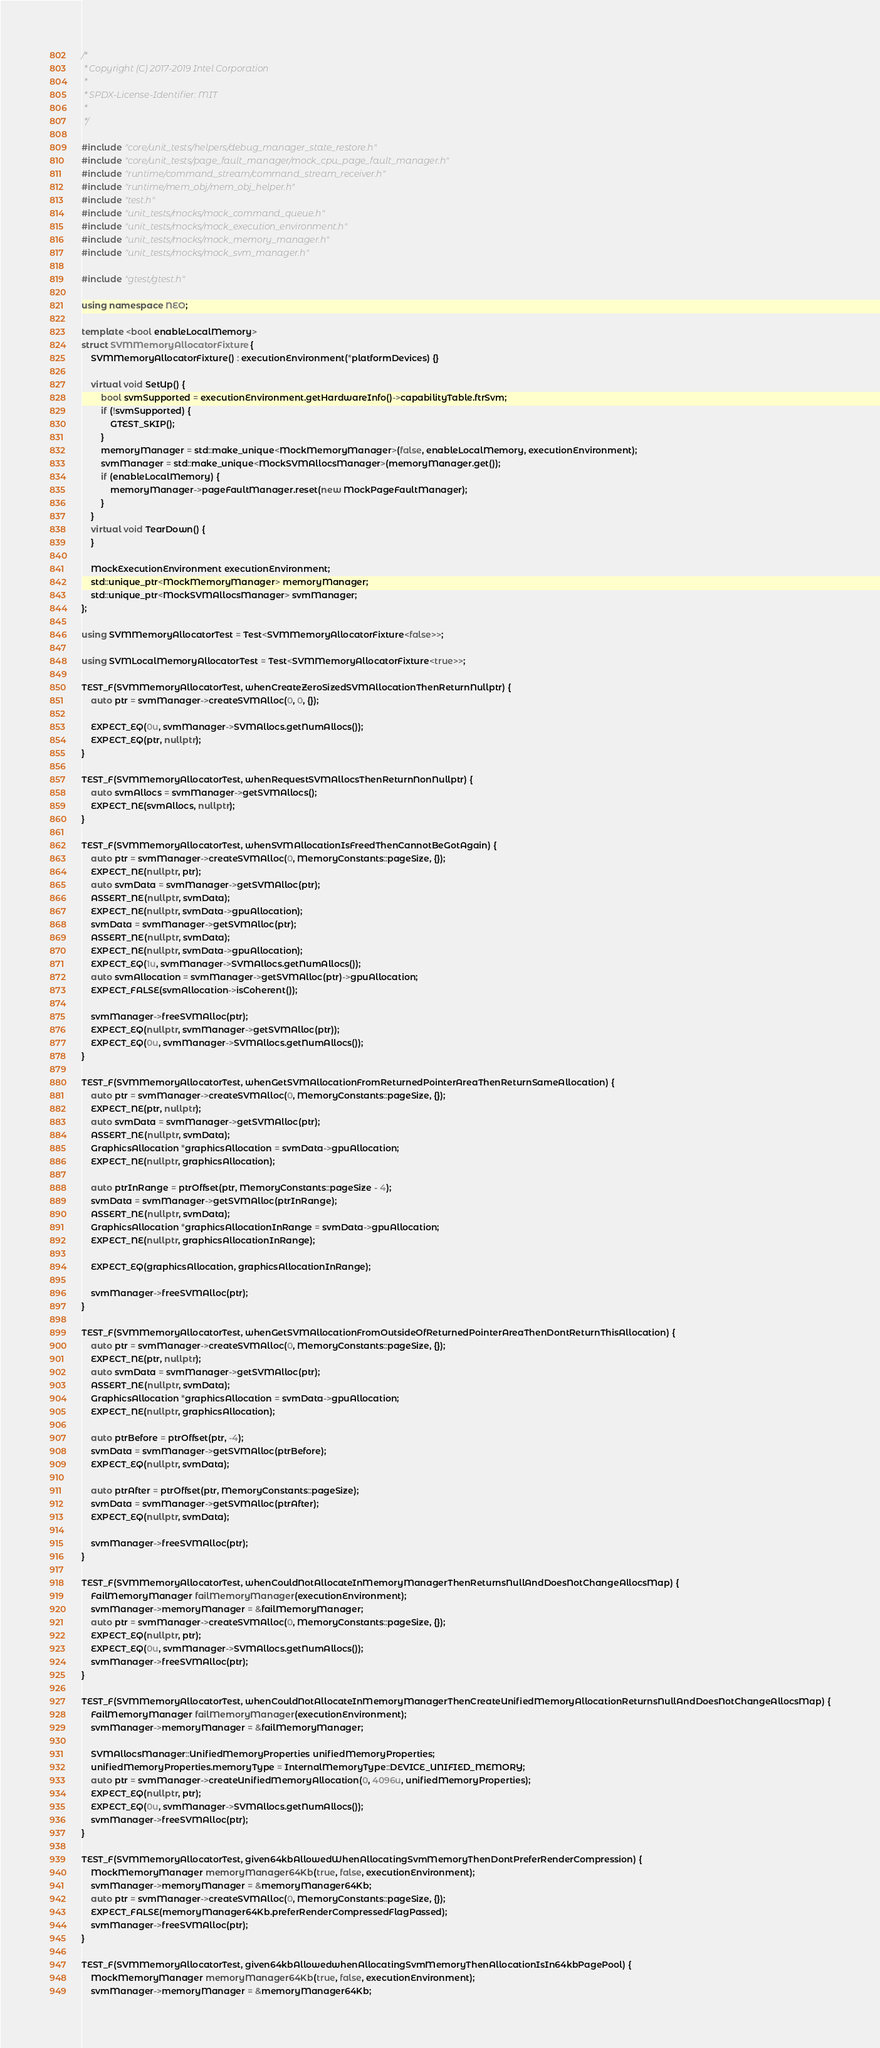<code> <loc_0><loc_0><loc_500><loc_500><_C++_>/*
 * Copyright (C) 2017-2019 Intel Corporation
 *
 * SPDX-License-Identifier: MIT
 *
 */

#include "core/unit_tests/helpers/debug_manager_state_restore.h"
#include "core/unit_tests/page_fault_manager/mock_cpu_page_fault_manager.h"
#include "runtime/command_stream/command_stream_receiver.h"
#include "runtime/mem_obj/mem_obj_helper.h"
#include "test.h"
#include "unit_tests/mocks/mock_command_queue.h"
#include "unit_tests/mocks/mock_execution_environment.h"
#include "unit_tests/mocks/mock_memory_manager.h"
#include "unit_tests/mocks/mock_svm_manager.h"

#include "gtest/gtest.h"

using namespace NEO;

template <bool enableLocalMemory>
struct SVMMemoryAllocatorFixture {
    SVMMemoryAllocatorFixture() : executionEnvironment(*platformDevices) {}

    virtual void SetUp() {
        bool svmSupported = executionEnvironment.getHardwareInfo()->capabilityTable.ftrSvm;
        if (!svmSupported) {
            GTEST_SKIP();
        }
        memoryManager = std::make_unique<MockMemoryManager>(false, enableLocalMemory, executionEnvironment);
        svmManager = std::make_unique<MockSVMAllocsManager>(memoryManager.get());
        if (enableLocalMemory) {
            memoryManager->pageFaultManager.reset(new MockPageFaultManager);
        }
    }
    virtual void TearDown() {
    }

    MockExecutionEnvironment executionEnvironment;
    std::unique_ptr<MockMemoryManager> memoryManager;
    std::unique_ptr<MockSVMAllocsManager> svmManager;
};

using SVMMemoryAllocatorTest = Test<SVMMemoryAllocatorFixture<false>>;

using SVMLocalMemoryAllocatorTest = Test<SVMMemoryAllocatorFixture<true>>;

TEST_F(SVMMemoryAllocatorTest, whenCreateZeroSizedSVMAllocationThenReturnNullptr) {
    auto ptr = svmManager->createSVMAlloc(0, 0, {});

    EXPECT_EQ(0u, svmManager->SVMAllocs.getNumAllocs());
    EXPECT_EQ(ptr, nullptr);
}

TEST_F(SVMMemoryAllocatorTest, whenRequestSVMAllocsThenReturnNonNullptr) {
    auto svmAllocs = svmManager->getSVMAllocs();
    EXPECT_NE(svmAllocs, nullptr);
}

TEST_F(SVMMemoryAllocatorTest, whenSVMAllocationIsFreedThenCannotBeGotAgain) {
    auto ptr = svmManager->createSVMAlloc(0, MemoryConstants::pageSize, {});
    EXPECT_NE(nullptr, ptr);
    auto svmData = svmManager->getSVMAlloc(ptr);
    ASSERT_NE(nullptr, svmData);
    EXPECT_NE(nullptr, svmData->gpuAllocation);
    svmData = svmManager->getSVMAlloc(ptr);
    ASSERT_NE(nullptr, svmData);
    EXPECT_NE(nullptr, svmData->gpuAllocation);
    EXPECT_EQ(1u, svmManager->SVMAllocs.getNumAllocs());
    auto svmAllocation = svmManager->getSVMAlloc(ptr)->gpuAllocation;
    EXPECT_FALSE(svmAllocation->isCoherent());

    svmManager->freeSVMAlloc(ptr);
    EXPECT_EQ(nullptr, svmManager->getSVMAlloc(ptr));
    EXPECT_EQ(0u, svmManager->SVMAllocs.getNumAllocs());
}

TEST_F(SVMMemoryAllocatorTest, whenGetSVMAllocationFromReturnedPointerAreaThenReturnSameAllocation) {
    auto ptr = svmManager->createSVMAlloc(0, MemoryConstants::pageSize, {});
    EXPECT_NE(ptr, nullptr);
    auto svmData = svmManager->getSVMAlloc(ptr);
    ASSERT_NE(nullptr, svmData);
    GraphicsAllocation *graphicsAllocation = svmData->gpuAllocation;
    EXPECT_NE(nullptr, graphicsAllocation);

    auto ptrInRange = ptrOffset(ptr, MemoryConstants::pageSize - 4);
    svmData = svmManager->getSVMAlloc(ptrInRange);
    ASSERT_NE(nullptr, svmData);
    GraphicsAllocation *graphicsAllocationInRange = svmData->gpuAllocation;
    EXPECT_NE(nullptr, graphicsAllocationInRange);

    EXPECT_EQ(graphicsAllocation, graphicsAllocationInRange);

    svmManager->freeSVMAlloc(ptr);
}

TEST_F(SVMMemoryAllocatorTest, whenGetSVMAllocationFromOutsideOfReturnedPointerAreaThenDontReturnThisAllocation) {
    auto ptr = svmManager->createSVMAlloc(0, MemoryConstants::pageSize, {});
    EXPECT_NE(ptr, nullptr);
    auto svmData = svmManager->getSVMAlloc(ptr);
    ASSERT_NE(nullptr, svmData);
    GraphicsAllocation *graphicsAllocation = svmData->gpuAllocation;
    EXPECT_NE(nullptr, graphicsAllocation);

    auto ptrBefore = ptrOffset(ptr, -4);
    svmData = svmManager->getSVMAlloc(ptrBefore);
    EXPECT_EQ(nullptr, svmData);

    auto ptrAfter = ptrOffset(ptr, MemoryConstants::pageSize);
    svmData = svmManager->getSVMAlloc(ptrAfter);
    EXPECT_EQ(nullptr, svmData);

    svmManager->freeSVMAlloc(ptr);
}

TEST_F(SVMMemoryAllocatorTest, whenCouldNotAllocateInMemoryManagerThenReturnsNullAndDoesNotChangeAllocsMap) {
    FailMemoryManager failMemoryManager(executionEnvironment);
    svmManager->memoryManager = &failMemoryManager;
    auto ptr = svmManager->createSVMAlloc(0, MemoryConstants::pageSize, {});
    EXPECT_EQ(nullptr, ptr);
    EXPECT_EQ(0u, svmManager->SVMAllocs.getNumAllocs());
    svmManager->freeSVMAlloc(ptr);
}

TEST_F(SVMMemoryAllocatorTest, whenCouldNotAllocateInMemoryManagerThenCreateUnifiedMemoryAllocationReturnsNullAndDoesNotChangeAllocsMap) {
    FailMemoryManager failMemoryManager(executionEnvironment);
    svmManager->memoryManager = &failMemoryManager;

    SVMAllocsManager::UnifiedMemoryProperties unifiedMemoryProperties;
    unifiedMemoryProperties.memoryType = InternalMemoryType::DEVICE_UNIFIED_MEMORY;
    auto ptr = svmManager->createUnifiedMemoryAllocation(0, 4096u, unifiedMemoryProperties);
    EXPECT_EQ(nullptr, ptr);
    EXPECT_EQ(0u, svmManager->SVMAllocs.getNumAllocs());
    svmManager->freeSVMAlloc(ptr);
}

TEST_F(SVMMemoryAllocatorTest, given64kbAllowedWhenAllocatingSvmMemoryThenDontPreferRenderCompression) {
    MockMemoryManager memoryManager64Kb(true, false, executionEnvironment);
    svmManager->memoryManager = &memoryManager64Kb;
    auto ptr = svmManager->createSVMAlloc(0, MemoryConstants::pageSize, {});
    EXPECT_FALSE(memoryManager64Kb.preferRenderCompressedFlagPassed);
    svmManager->freeSVMAlloc(ptr);
}

TEST_F(SVMMemoryAllocatorTest, given64kbAllowedwhenAllocatingSvmMemoryThenAllocationIsIn64kbPagePool) {
    MockMemoryManager memoryManager64Kb(true, false, executionEnvironment);
    svmManager->memoryManager = &memoryManager64Kb;</code> 